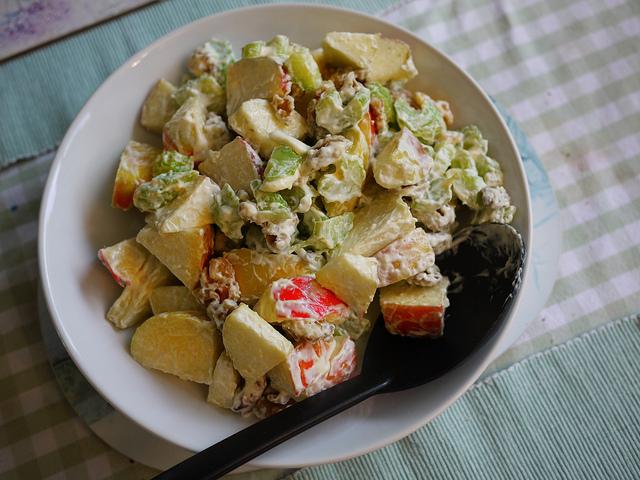What color is the spoon?
Write a very short answer. Black. Can this meal be consumed by a vegetarian?
Keep it brief. Yes. Does this meal have nuts in it?
Short answer required. Yes. 